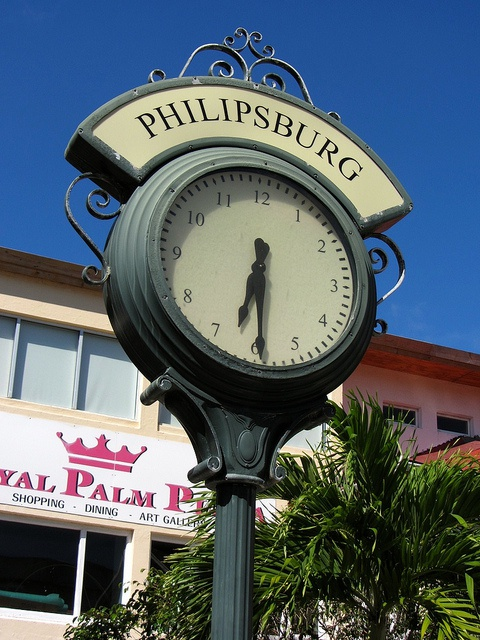Describe the objects in this image and their specific colors. I can see a clock in blue, darkgray, gray, black, and beige tones in this image. 